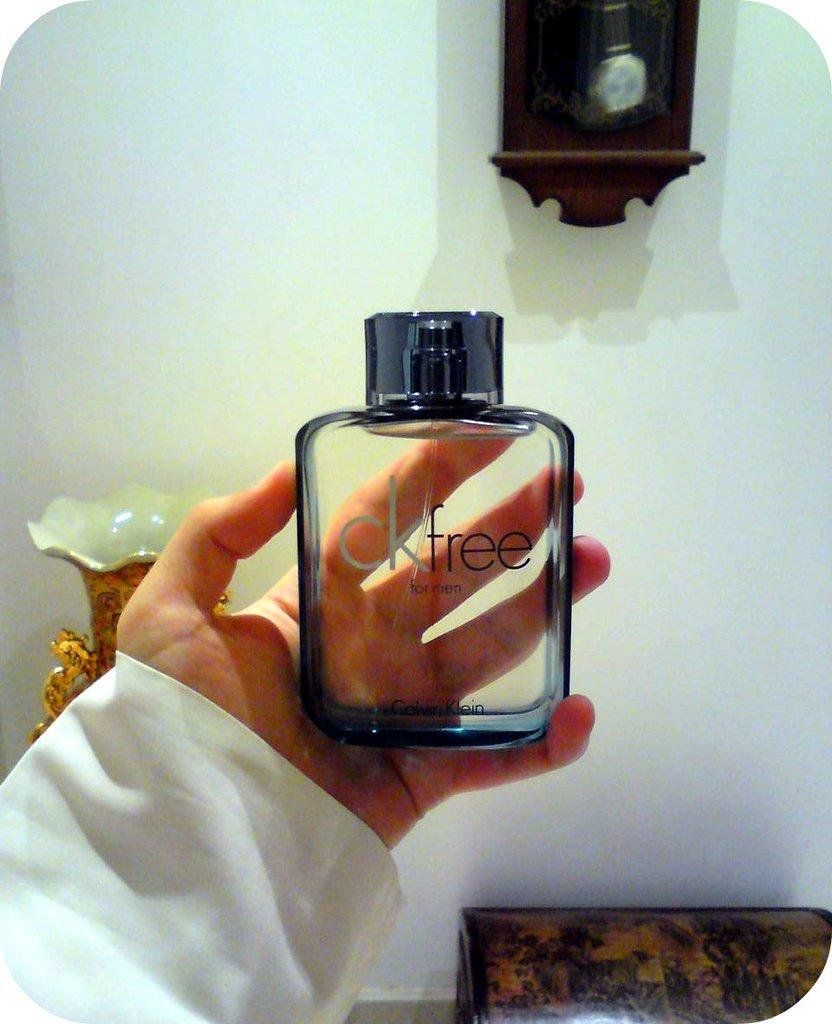Provide a one-sentence caption for the provided image. A bottle of calvin klein that someone is holding. 